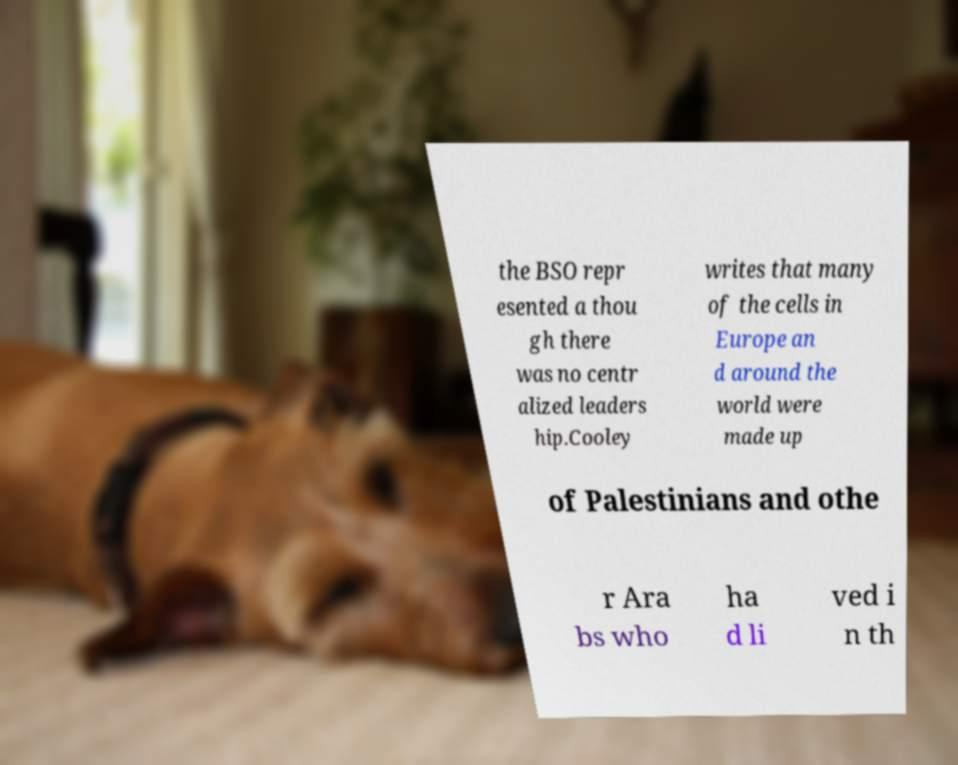There's text embedded in this image that I need extracted. Can you transcribe it verbatim? the BSO repr esented a thou gh there was no centr alized leaders hip.Cooley writes that many of the cells in Europe an d around the world were made up of Palestinians and othe r Ara bs who ha d li ved i n th 